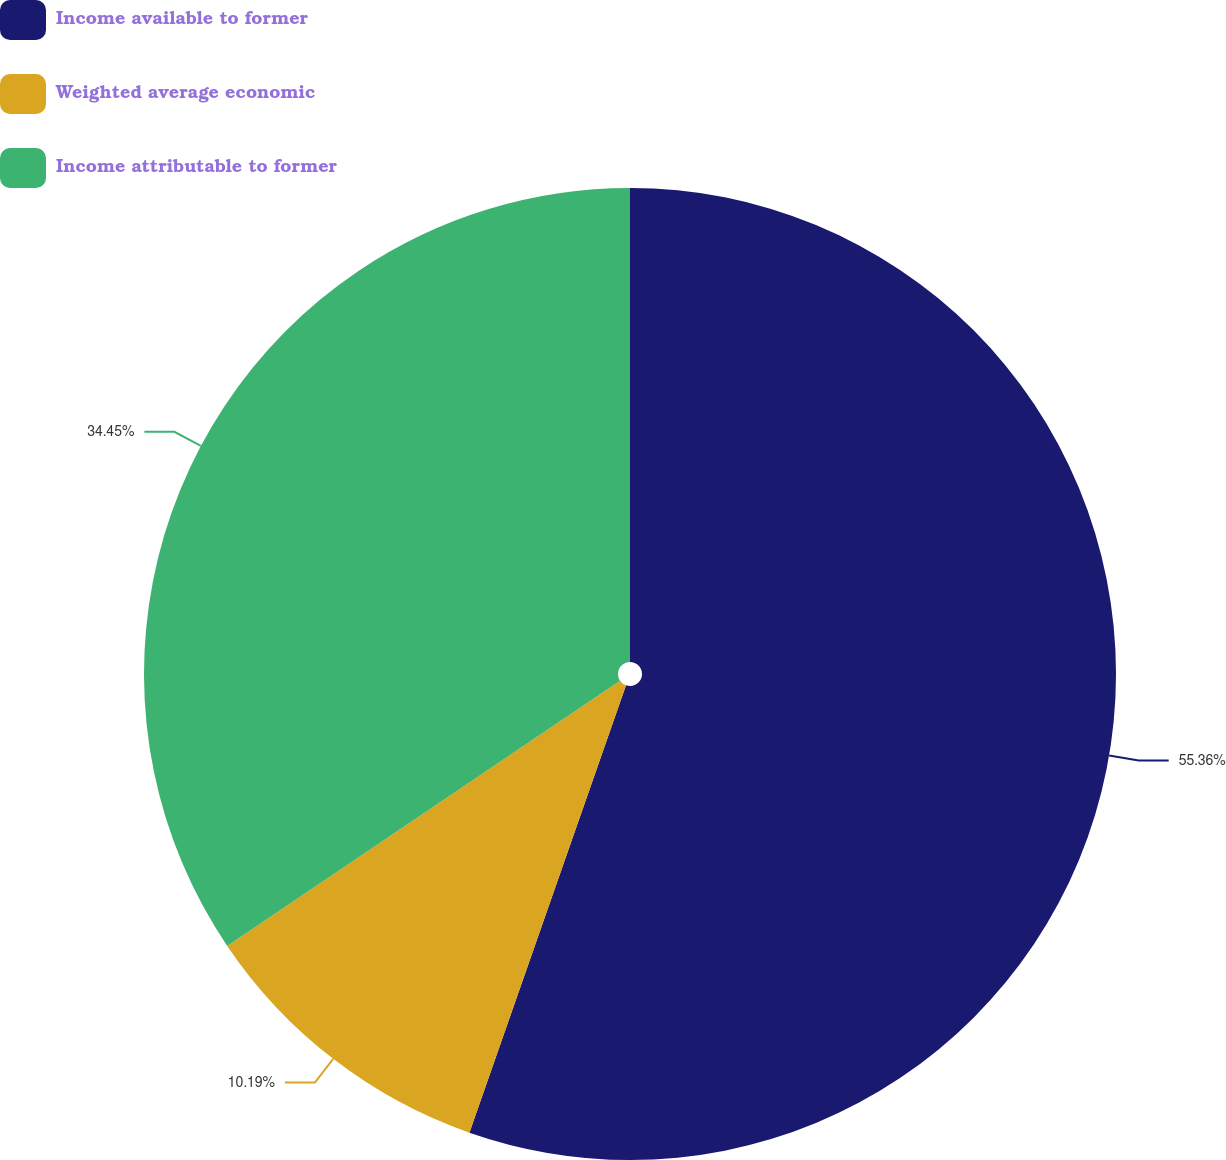Convert chart. <chart><loc_0><loc_0><loc_500><loc_500><pie_chart><fcel>Income available to former<fcel>Weighted average economic<fcel>Income attributable to former<nl><fcel>55.36%<fcel>10.19%<fcel>34.45%<nl></chart> 